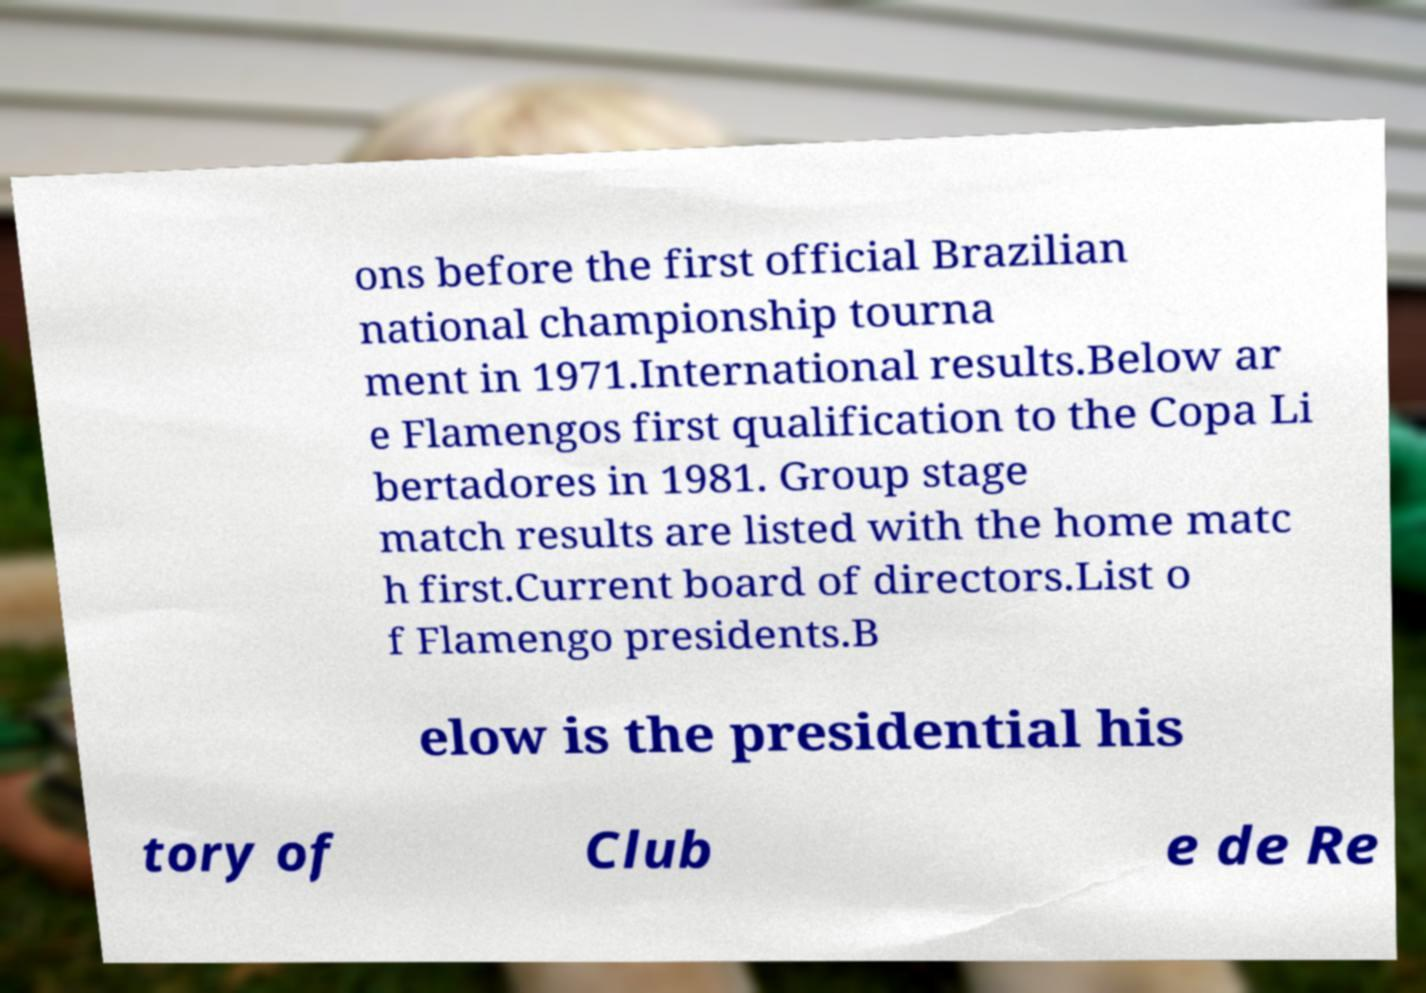Can you read and provide the text displayed in the image?This photo seems to have some interesting text. Can you extract and type it out for me? ons before the first official Brazilian national championship tourna ment in 1971.International results.Below ar e Flamengos first qualification to the Copa Li bertadores in 1981. Group stage match results are listed with the home matc h first.Current board of directors.List o f Flamengo presidents.B elow is the presidential his tory of Club e de Re 